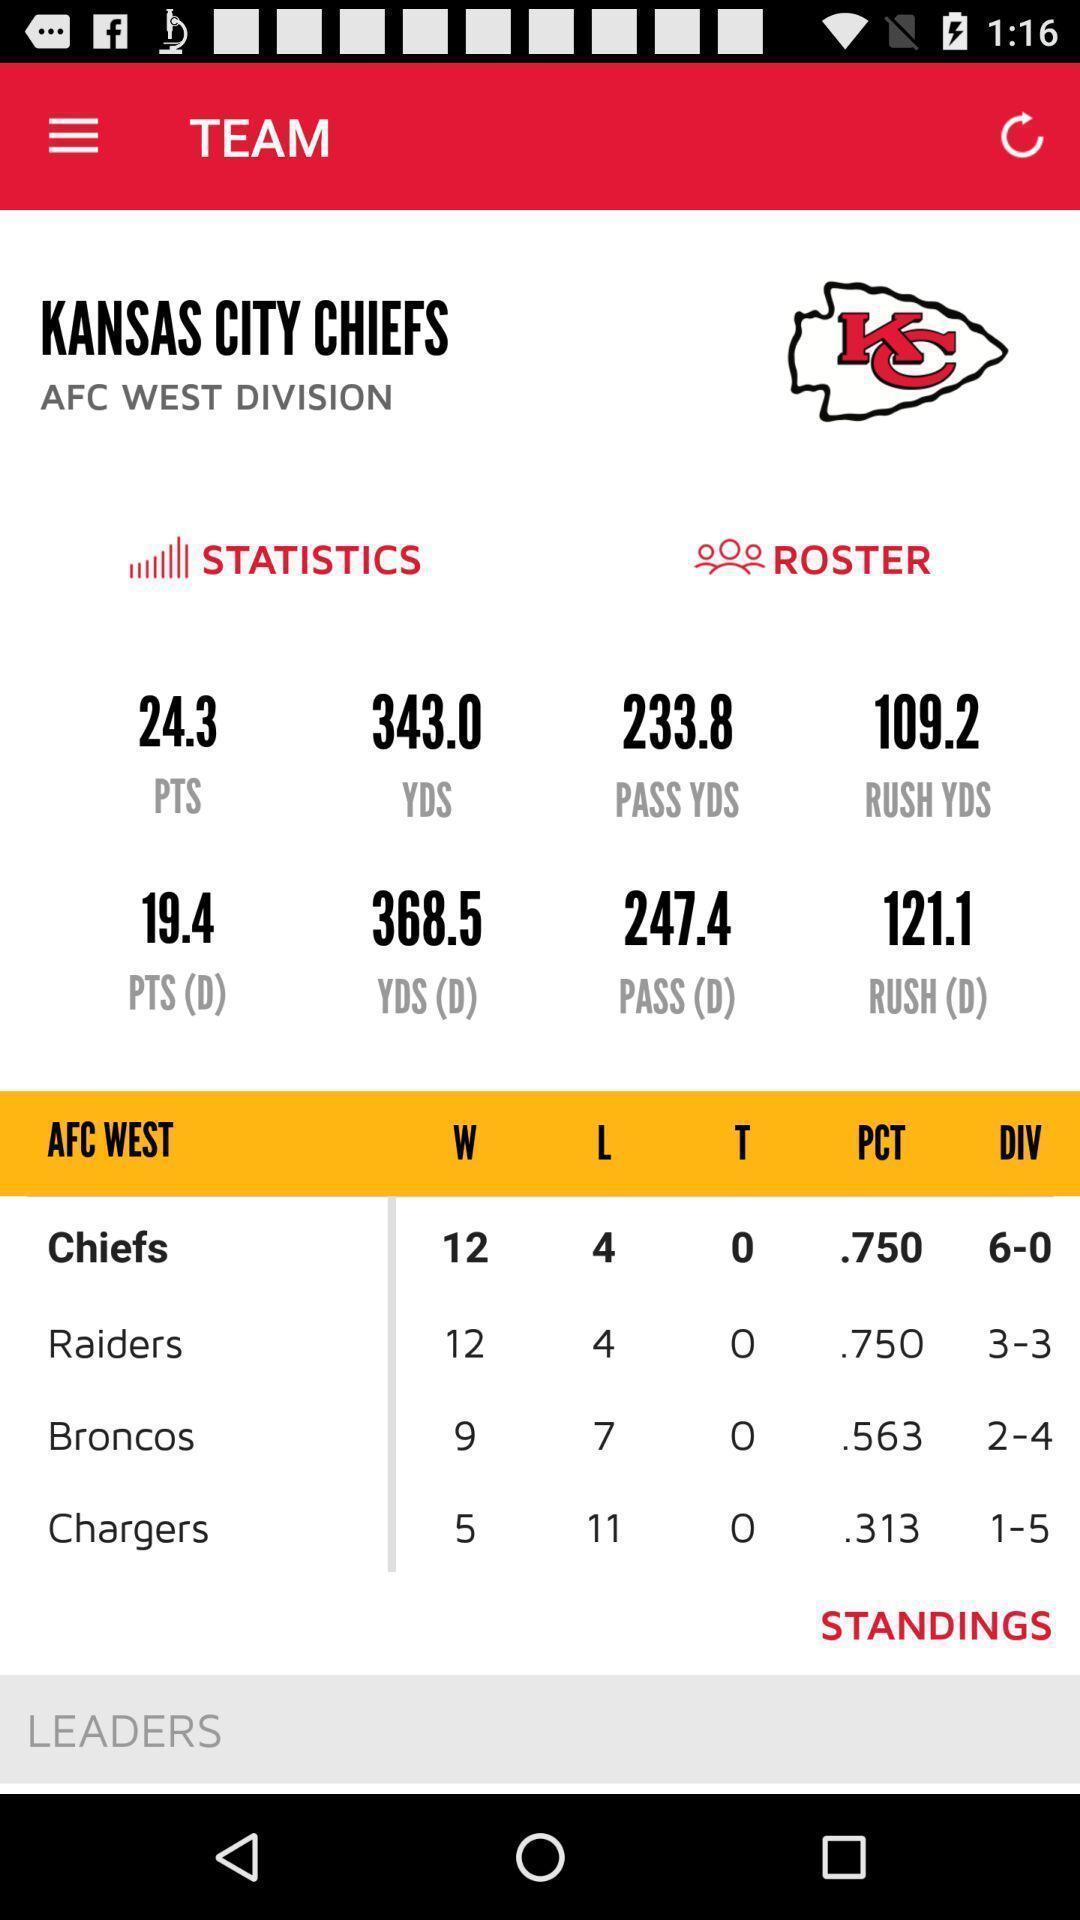Summarize the main components in this picture. Screen displaying the team score of a game. 